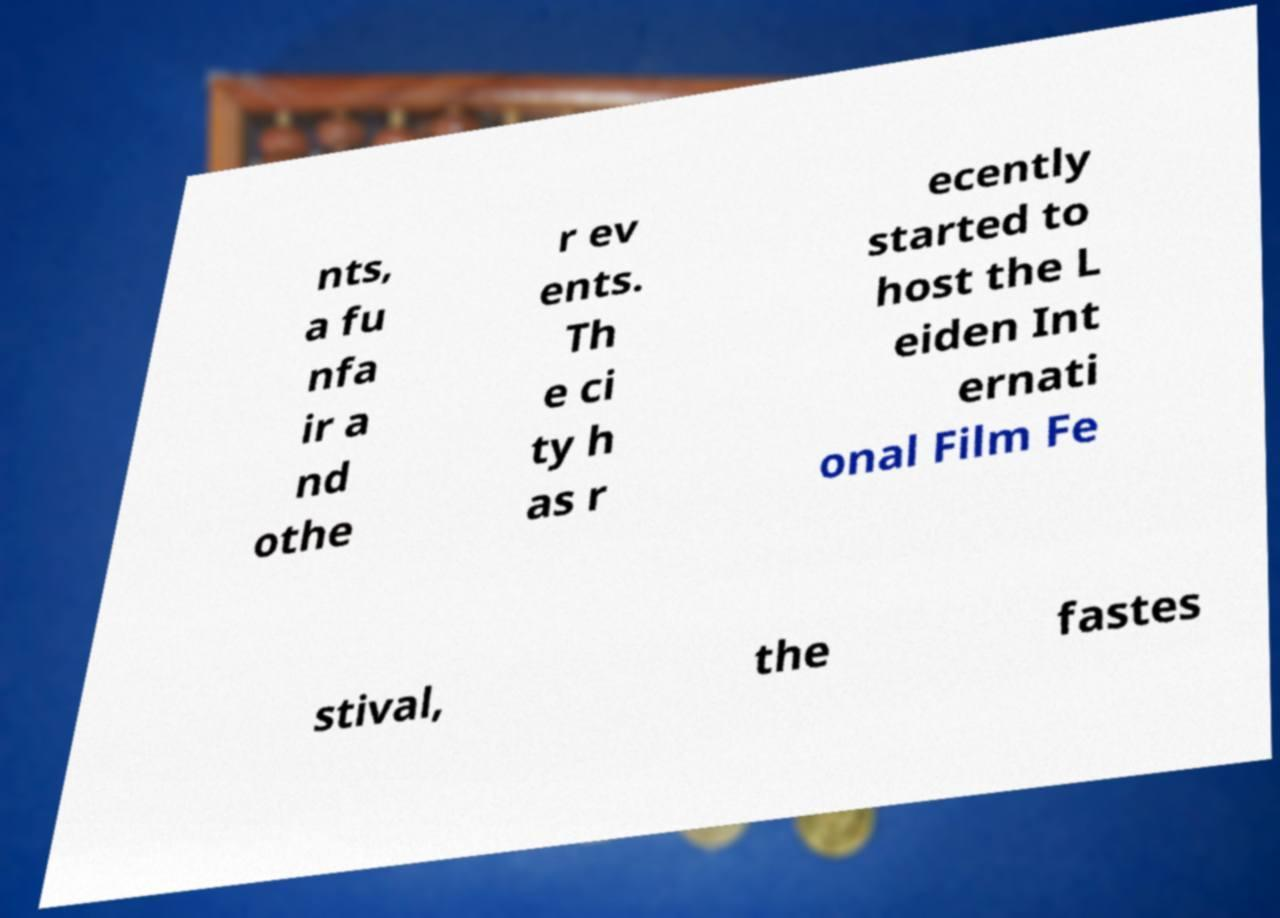Please identify and transcribe the text found in this image. nts, a fu nfa ir a nd othe r ev ents. Th e ci ty h as r ecently started to host the L eiden Int ernati onal Film Fe stival, the fastes 